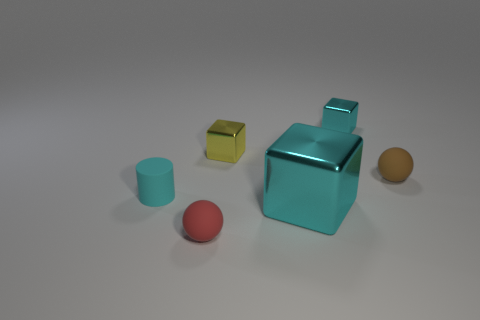Subtract all gray balls. How many cyan cubes are left? 2 Add 2 large things. How many objects exist? 8 Subtract all cylinders. How many objects are left? 5 Subtract 0 purple cylinders. How many objects are left? 6 Subtract all red matte objects. Subtract all brown balls. How many objects are left? 4 Add 3 small blocks. How many small blocks are left? 5 Add 2 tiny cyan blocks. How many tiny cyan blocks exist? 3 